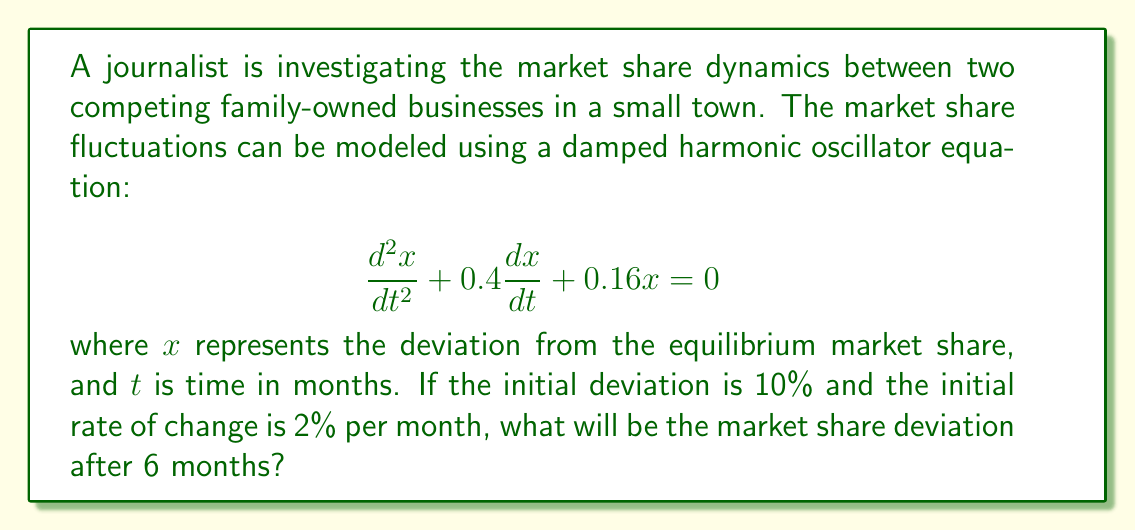Can you solve this math problem? To solve this problem, we need to follow these steps:

1) The general solution for a damped harmonic oscillator equation is:

   $$x(t) = e^{-\beta t}(A\cos(\omega t) + B\sin(\omega t))$$

   where $\beta$ is the damping coefficient and $\omega$ is the angular frequency.

2) From the given equation, we can identify:
   
   $\beta = 0.2$ (half of the coefficient of $\frac{dx}{dt}$)
   $\omega = \sqrt{0.16 - 0.2^2} = 0.2$

3) We need to find $A$ and $B$ using the initial conditions:
   
   $x(0) = 0.1$ (10% initial deviation)
   $x'(0) = 0.02$ (2% initial rate of change)

4) Using these conditions:

   $x(0) = A = 0.1$
   
   $x'(0) = -0.2A + 0.2B = 0.02$

   Solving for $B$: $B = 0.11$

5) Therefore, our solution is:

   $$x(t) = e^{-0.2t}(0.1\cos(0.2t) + 0.11\sin(0.2t))$$

6) To find the deviation after 6 months, we substitute $t = 6$:

   $$x(6) = e^{-1.2}(0.1\cos(1.2) + 0.11\sin(1.2))$$

7) Calculating this:

   $$x(6) \approx 0.3012 \times (0.1 \times 0.3624 + 0.11 \times 0.9322) \approx 0.0361$$
Answer: The market share deviation after 6 months will be approximately 3.61%. 